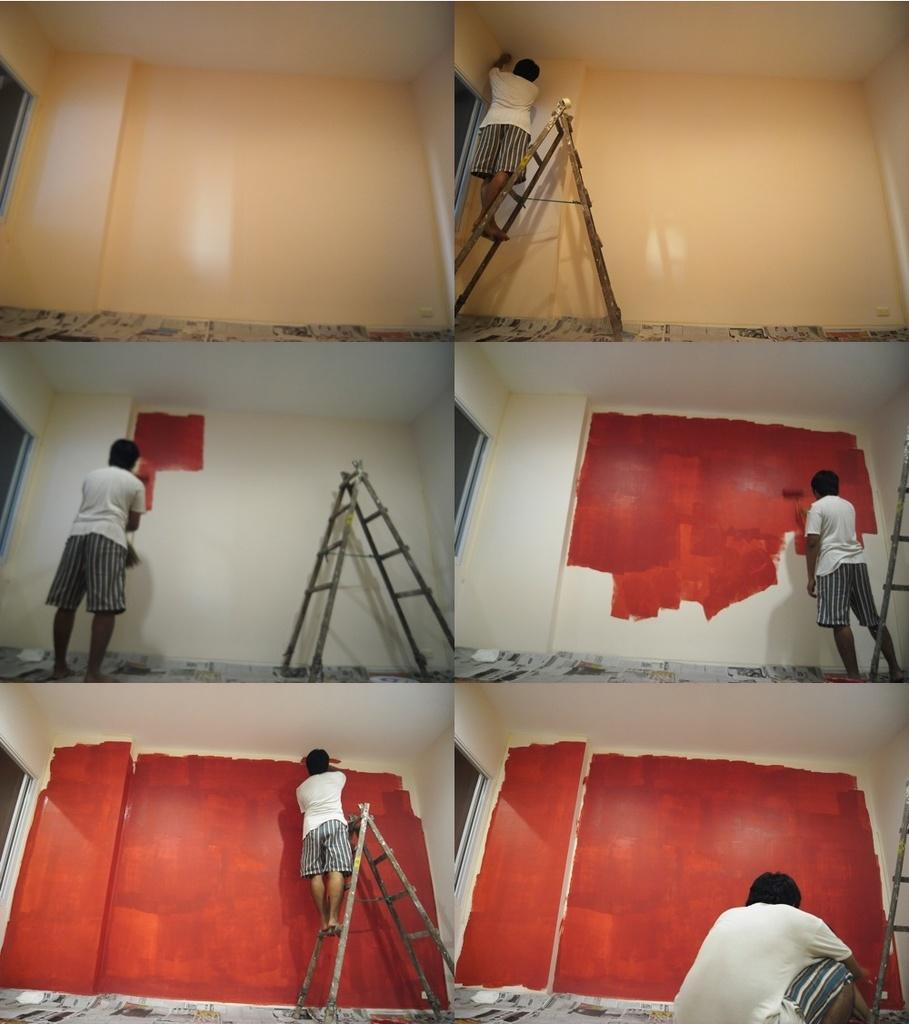What type of location is depicted in the image? The image is of a college. Can you describe any people in the image? There is a person in the image. What objects are present in the image that might be used for climbing or reaching higher places? There is a ladder in the image. What structures are visible in the image? There is a wall and a roof in the image. What is visible at the bottom of the image? There is ground visible in the image. What objects can be seen on the ground? There are objects on the ground. How many beans are being held by the person in the image? There are no beans present in the image. 